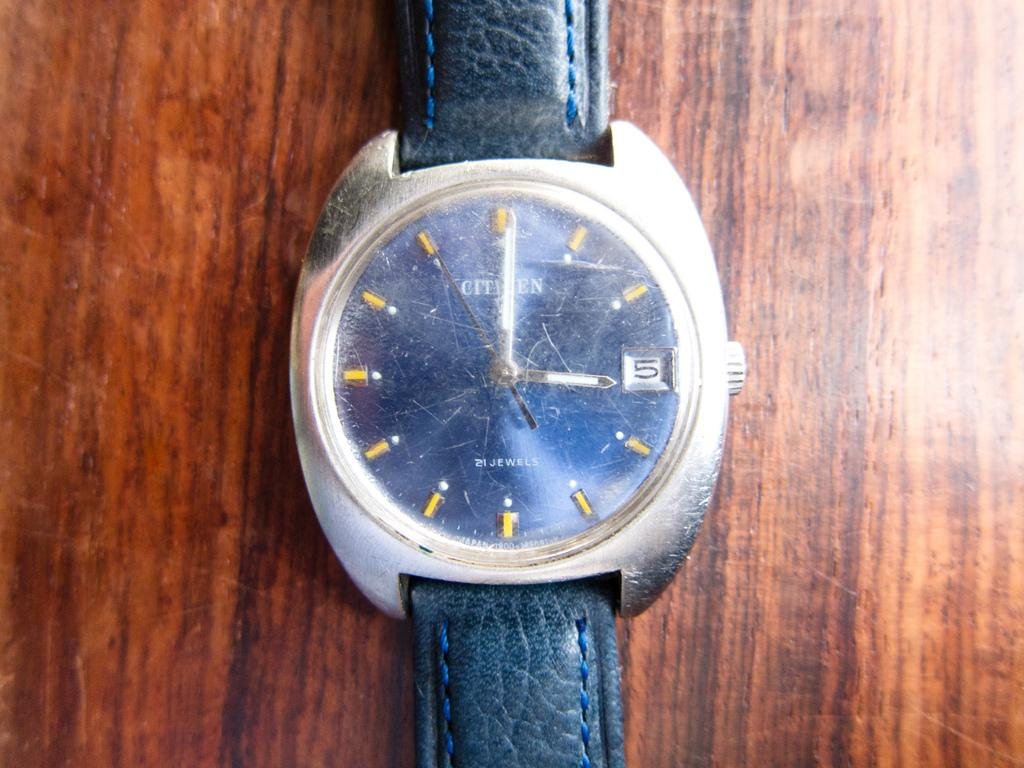Provide a one-sentence caption for the provided image. A Citizens watch with cracked glass over the clock piece. 